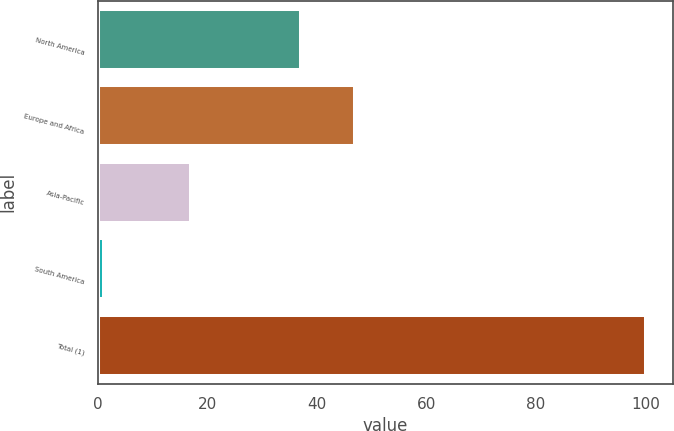Convert chart. <chart><loc_0><loc_0><loc_500><loc_500><bar_chart><fcel>North America<fcel>Europe and Africa<fcel>Asia-Pacific<fcel>South America<fcel>Total (1)<nl><fcel>37<fcel>46.9<fcel>17<fcel>1<fcel>100<nl></chart> 